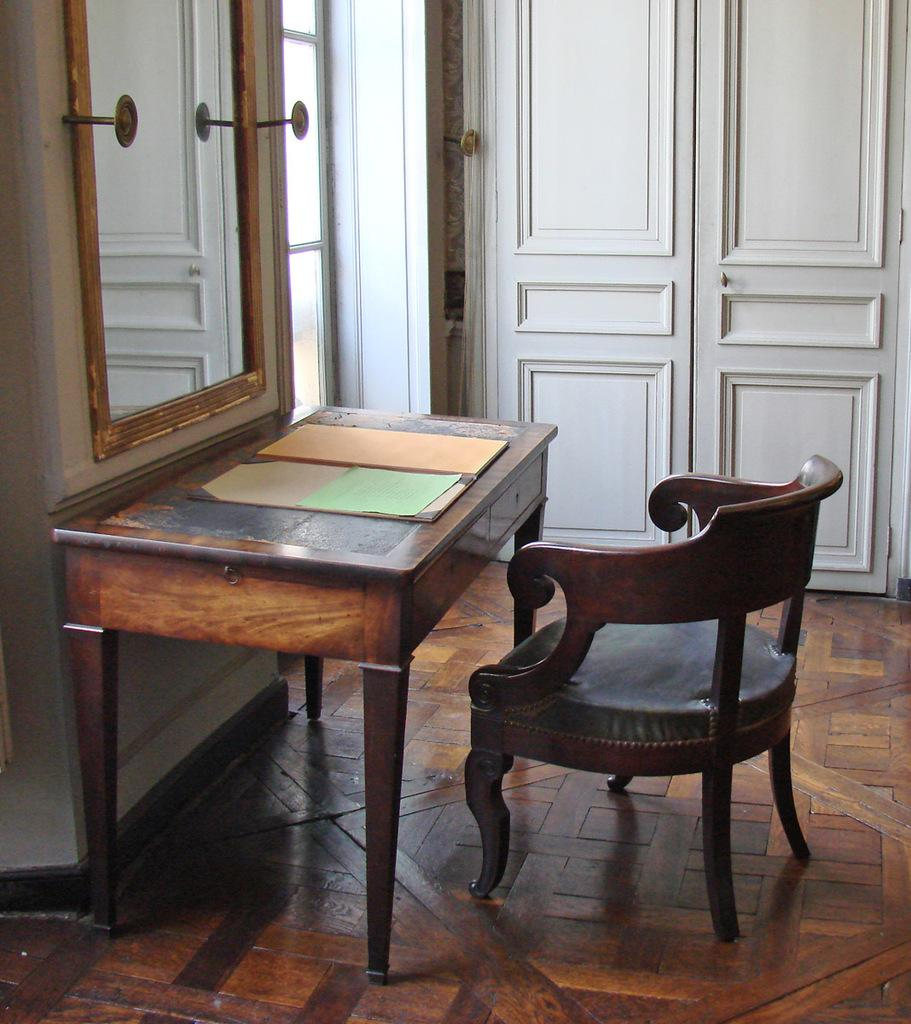What piece of furniture is in the image? There is a table in the image. How is the table positioned in the image? The table is on a chair. Where is the table and chair located? The table and chair are on the floor. What can be seen in the background of the image? There are walls in the background of the image. What features are present in the walls? There are doors and a mirror in the walls. Can you describe the zephyr that is present in the image? There is no zephyr present in the image; a zephyr refers to a gentle breeze, which is not a tangible object that can be seen in a photograph. 